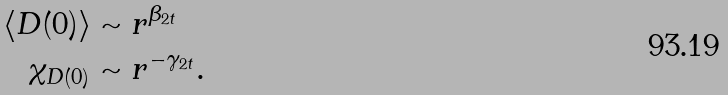<formula> <loc_0><loc_0><loc_500><loc_500>\langle D ( 0 ) \rangle & \sim r ^ { \beta _ { 2 t } } \\ \chi _ { D ( 0 ) } & \sim r ^ { - \gamma _ { 2 t } } .</formula> 